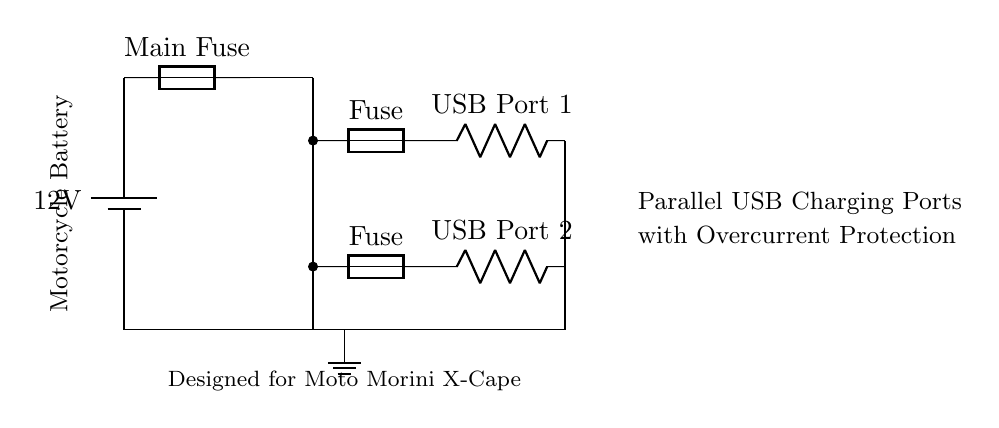What is the voltage provided by the battery? The diagram indicates the battery voltage is labeled as 12 volts. This information can be found near the battery symbol in the circuit.
Answer: 12 volts How many USB ports are in this circuit? The diagram shows two separate branches for USB ports, each represented with a label next to a resistor, indicating two distinct USB charging ports.
Answer: Two What component ensures protection against overcurrent for each USB port? Each USB port has a fuse connected in series, allowing it to protect against overcurrent by breaking the circuit if the current exceeds a certain limit. Each of these is marked explicitly in the diagram.
Answer: Fuse What is the significance of having the USB ports in parallel? Having the USB ports in parallel means each port can operate independently, allowing for the same voltage across each port and ensuring that if one port fails, the others will still function. This configuration is crucial for reliability in charging multiple devices simultaneously.
Answer: Independent operation What is the total current distribution among the USB ports? In a parallel circuit, the total current supplied by the battery is distributed among the branches according to the resistance of each branch. Although the diagram does not illustrate specific current values, the fundamental principle dictates that the current through each USB port will vary based on the load connected to them.
Answer: Distributed current What is the purpose of the main fuse in this circuit? The main fuse protects the entire circuit by preventing excessive current from the battery from reaching the USB ports. If the total current exceeds the fuse rating, the fuse will blow, cutting off the power supply as a safety measure, thus protecting both the connected devices and the wiring.
Answer: Overcurrent protection 